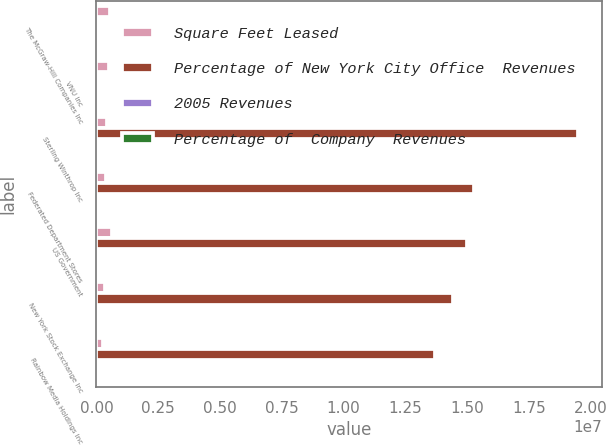<chart> <loc_0><loc_0><loc_500><loc_500><stacked_bar_chart><ecel><fcel>The McGraw-Hill Companies Inc<fcel>VNU Inc<fcel>Sterling Winthrop Inc<fcel>Federated Department Stores<fcel>US Government<fcel>New York Stock Exchange Inc<fcel>Rainbow Media Holdings Inc<nl><fcel>Square Feet Leased<fcel>536000<fcel>515000<fcel>429000<fcel>375000<fcel>639000<fcel>348000<fcel>269000<nl><fcel>Percentage of New York City Office  Revenues<fcel>3.3<fcel>3.3<fcel>1.9479e+07<fcel>1.5275e+07<fcel>1.4988e+07<fcel>1.4416e+07<fcel>1.3691e+07<nl><fcel>2005 Revenues<fcel>3.4<fcel>3.2<fcel>3.1<fcel>2.4<fcel>2.4<fcel>2.3<fcel>2.2<nl><fcel>Percentage of  Company  Revenues<fcel>0.8<fcel>0.8<fcel>0.8<fcel>0.6<fcel>0.6<fcel>0.6<fcel>0.5<nl></chart> 